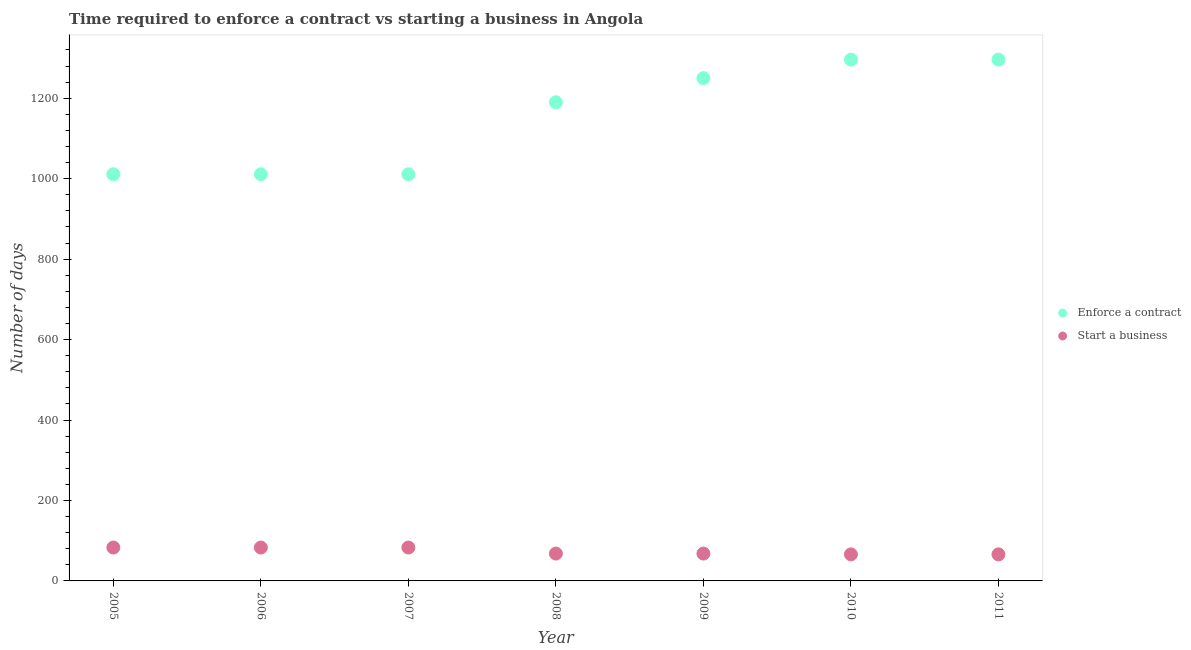What is the number of days to start a business in 2010?
Your answer should be compact. 66. Across all years, what is the maximum number of days to enforece a contract?
Make the answer very short. 1296. Across all years, what is the minimum number of days to start a business?
Offer a terse response. 66. In which year was the number of days to start a business maximum?
Provide a succinct answer. 2005. What is the total number of days to start a business in the graph?
Your response must be concise. 517. What is the difference between the number of days to start a business in 2006 and that in 2007?
Provide a succinct answer. 0. What is the difference between the number of days to enforece a contract in 2010 and the number of days to start a business in 2008?
Give a very brief answer. 1228. What is the average number of days to start a business per year?
Your response must be concise. 73.86. In the year 2010, what is the difference between the number of days to enforece a contract and number of days to start a business?
Make the answer very short. 1230. What is the ratio of the number of days to start a business in 2006 to that in 2007?
Keep it short and to the point. 1. What is the difference between the highest and the second highest number of days to enforece a contract?
Keep it short and to the point. 0. What is the difference between the highest and the lowest number of days to start a business?
Provide a short and direct response. 17. Is the sum of the number of days to enforece a contract in 2005 and 2010 greater than the maximum number of days to start a business across all years?
Keep it short and to the point. Yes. Does the number of days to enforece a contract monotonically increase over the years?
Offer a very short reply. No. Is the number of days to enforece a contract strictly greater than the number of days to start a business over the years?
Give a very brief answer. Yes. How many dotlines are there?
Provide a succinct answer. 2. Are the values on the major ticks of Y-axis written in scientific E-notation?
Your answer should be very brief. No. Does the graph contain any zero values?
Your response must be concise. No. Does the graph contain grids?
Make the answer very short. No. Where does the legend appear in the graph?
Your response must be concise. Center right. How many legend labels are there?
Keep it short and to the point. 2. How are the legend labels stacked?
Offer a terse response. Vertical. What is the title of the graph?
Your answer should be compact. Time required to enforce a contract vs starting a business in Angola. What is the label or title of the Y-axis?
Your answer should be compact. Number of days. What is the Number of days in Enforce a contract in 2005?
Your answer should be compact. 1011. What is the Number of days of Enforce a contract in 2006?
Provide a succinct answer. 1011. What is the Number of days of Start a business in 2006?
Offer a terse response. 83. What is the Number of days of Enforce a contract in 2007?
Your answer should be very brief. 1011. What is the Number of days of Start a business in 2007?
Make the answer very short. 83. What is the Number of days of Enforce a contract in 2008?
Your response must be concise. 1190. What is the Number of days in Start a business in 2008?
Your answer should be very brief. 68. What is the Number of days in Enforce a contract in 2009?
Ensure brevity in your answer.  1250. What is the Number of days in Start a business in 2009?
Keep it short and to the point. 68. What is the Number of days of Enforce a contract in 2010?
Provide a succinct answer. 1296. What is the Number of days in Enforce a contract in 2011?
Your answer should be compact. 1296. Across all years, what is the maximum Number of days in Enforce a contract?
Your response must be concise. 1296. Across all years, what is the maximum Number of days in Start a business?
Make the answer very short. 83. Across all years, what is the minimum Number of days in Enforce a contract?
Offer a very short reply. 1011. Across all years, what is the minimum Number of days of Start a business?
Provide a short and direct response. 66. What is the total Number of days in Enforce a contract in the graph?
Your answer should be very brief. 8065. What is the total Number of days in Start a business in the graph?
Provide a succinct answer. 517. What is the difference between the Number of days in Enforce a contract in 2005 and that in 2006?
Your answer should be compact. 0. What is the difference between the Number of days in Enforce a contract in 2005 and that in 2007?
Offer a terse response. 0. What is the difference between the Number of days in Enforce a contract in 2005 and that in 2008?
Provide a short and direct response. -179. What is the difference between the Number of days in Start a business in 2005 and that in 2008?
Give a very brief answer. 15. What is the difference between the Number of days of Enforce a contract in 2005 and that in 2009?
Your answer should be compact. -239. What is the difference between the Number of days in Enforce a contract in 2005 and that in 2010?
Your response must be concise. -285. What is the difference between the Number of days of Start a business in 2005 and that in 2010?
Provide a succinct answer. 17. What is the difference between the Number of days of Enforce a contract in 2005 and that in 2011?
Your response must be concise. -285. What is the difference between the Number of days in Start a business in 2006 and that in 2007?
Give a very brief answer. 0. What is the difference between the Number of days of Enforce a contract in 2006 and that in 2008?
Make the answer very short. -179. What is the difference between the Number of days in Start a business in 2006 and that in 2008?
Your answer should be compact. 15. What is the difference between the Number of days in Enforce a contract in 2006 and that in 2009?
Ensure brevity in your answer.  -239. What is the difference between the Number of days of Enforce a contract in 2006 and that in 2010?
Provide a succinct answer. -285. What is the difference between the Number of days of Enforce a contract in 2006 and that in 2011?
Keep it short and to the point. -285. What is the difference between the Number of days in Enforce a contract in 2007 and that in 2008?
Your response must be concise. -179. What is the difference between the Number of days of Start a business in 2007 and that in 2008?
Give a very brief answer. 15. What is the difference between the Number of days in Enforce a contract in 2007 and that in 2009?
Provide a succinct answer. -239. What is the difference between the Number of days of Start a business in 2007 and that in 2009?
Your answer should be compact. 15. What is the difference between the Number of days of Enforce a contract in 2007 and that in 2010?
Your answer should be compact. -285. What is the difference between the Number of days in Start a business in 2007 and that in 2010?
Provide a succinct answer. 17. What is the difference between the Number of days of Enforce a contract in 2007 and that in 2011?
Offer a terse response. -285. What is the difference between the Number of days in Start a business in 2007 and that in 2011?
Ensure brevity in your answer.  17. What is the difference between the Number of days in Enforce a contract in 2008 and that in 2009?
Provide a succinct answer. -60. What is the difference between the Number of days of Enforce a contract in 2008 and that in 2010?
Your answer should be very brief. -106. What is the difference between the Number of days in Start a business in 2008 and that in 2010?
Provide a succinct answer. 2. What is the difference between the Number of days of Enforce a contract in 2008 and that in 2011?
Offer a terse response. -106. What is the difference between the Number of days in Enforce a contract in 2009 and that in 2010?
Offer a terse response. -46. What is the difference between the Number of days of Start a business in 2009 and that in 2010?
Your answer should be compact. 2. What is the difference between the Number of days of Enforce a contract in 2009 and that in 2011?
Give a very brief answer. -46. What is the difference between the Number of days of Start a business in 2009 and that in 2011?
Give a very brief answer. 2. What is the difference between the Number of days of Enforce a contract in 2005 and the Number of days of Start a business in 2006?
Provide a short and direct response. 928. What is the difference between the Number of days in Enforce a contract in 2005 and the Number of days in Start a business in 2007?
Make the answer very short. 928. What is the difference between the Number of days in Enforce a contract in 2005 and the Number of days in Start a business in 2008?
Keep it short and to the point. 943. What is the difference between the Number of days of Enforce a contract in 2005 and the Number of days of Start a business in 2009?
Your response must be concise. 943. What is the difference between the Number of days of Enforce a contract in 2005 and the Number of days of Start a business in 2010?
Give a very brief answer. 945. What is the difference between the Number of days of Enforce a contract in 2005 and the Number of days of Start a business in 2011?
Make the answer very short. 945. What is the difference between the Number of days in Enforce a contract in 2006 and the Number of days in Start a business in 2007?
Give a very brief answer. 928. What is the difference between the Number of days of Enforce a contract in 2006 and the Number of days of Start a business in 2008?
Offer a terse response. 943. What is the difference between the Number of days of Enforce a contract in 2006 and the Number of days of Start a business in 2009?
Offer a terse response. 943. What is the difference between the Number of days in Enforce a contract in 2006 and the Number of days in Start a business in 2010?
Give a very brief answer. 945. What is the difference between the Number of days of Enforce a contract in 2006 and the Number of days of Start a business in 2011?
Keep it short and to the point. 945. What is the difference between the Number of days in Enforce a contract in 2007 and the Number of days in Start a business in 2008?
Offer a terse response. 943. What is the difference between the Number of days in Enforce a contract in 2007 and the Number of days in Start a business in 2009?
Make the answer very short. 943. What is the difference between the Number of days in Enforce a contract in 2007 and the Number of days in Start a business in 2010?
Your answer should be compact. 945. What is the difference between the Number of days in Enforce a contract in 2007 and the Number of days in Start a business in 2011?
Make the answer very short. 945. What is the difference between the Number of days of Enforce a contract in 2008 and the Number of days of Start a business in 2009?
Make the answer very short. 1122. What is the difference between the Number of days of Enforce a contract in 2008 and the Number of days of Start a business in 2010?
Provide a short and direct response. 1124. What is the difference between the Number of days of Enforce a contract in 2008 and the Number of days of Start a business in 2011?
Offer a terse response. 1124. What is the difference between the Number of days in Enforce a contract in 2009 and the Number of days in Start a business in 2010?
Offer a terse response. 1184. What is the difference between the Number of days of Enforce a contract in 2009 and the Number of days of Start a business in 2011?
Offer a terse response. 1184. What is the difference between the Number of days of Enforce a contract in 2010 and the Number of days of Start a business in 2011?
Provide a succinct answer. 1230. What is the average Number of days in Enforce a contract per year?
Your response must be concise. 1152.14. What is the average Number of days of Start a business per year?
Provide a short and direct response. 73.86. In the year 2005, what is the difference between the Number of days in Enforce a contract and Number of days in Start a business?
Provide a succinct answer. 928. In the year 2006, what is the difference between the Number of days of Enforce a contract and Number of days of Start a business?
Provide a succinct answer. 928. In the year 2007, what is the difference between the Number of days in Enforce a contract and Number of days in Start a business?
Give a very brief answer. 928. In the year 2008, what is the difference between the Number of days in Enforce a contract and Number of days in Start a business?
Your answer should be very brief. 1122. In the year 2009, what is the difference between the Number of days of Enforce a contract and Number of days of Start a business?
Offer a terse response. 1182. In the year 2010, what is the difference between the Number of days of Enforce a contract and Number of days of Start a business?
Your answer should be very brief. 1230. In the year 2011, what is the difference between the Number of days in Enforce a contract and Number of days in Start a business?
Offer a very short reply. 1230. What is the ratio of the Number of days of Enforce a contract in 2005 to that in 2006?
Provide a short and direct response. 1. What is the ratio of the Number of days in Start a business in 2005 to that in 2006?
Offer a very short reply. 1. What is the ratio of the Number of days in Enforce a contract in 2005 to that in 2008?
Offer a terse response. 0.85. What is the ratio of the Number of days in Start a business in 2005 to that in 2008?
Give a very brief answer. 1.22. What is the ratio of the Number of days in Enforce a contract in 2005 to that in 2009?
Provide a succinct answer. 0.81. What is the ratio of the Number of days in Start a business in 2005 to that in 2009?
Keep it short and to the point. 1.22. What is the ratio of the Number of days in Enforce a contract in 2005 to that in 2010?
Make the answer very short. 0.78. What is the ratio of the Number of days of Start a business in 2005 to that in 2010?
Offer a very short reply. 1.26. What is the ratio of the Number of days in Enforce a contract in 2005 to that in 2011?
Your answer should be very brief. 0.78. What is the ratio of the Number of days of Start a business in 2005 to that in 2011?
Provide a short and direct response. 1.26. What is the ratio of the Number of days in Start a business in 2006 to that in 2007?
Your answer should be very brief. 1. What is the ratio of the Number of days of Enforce a contract in 2006 to that in 2008?
Ensure brevity in your answer.  0.85. What is the ratio of the Number of days in Start a business in 2006 to that in 2008?
Keep it short and to the point. 1.22. What is the ratio of the Number of days in Enforce a contract in 2006 to that in 2009?
Offer a very short reply. 0.81. What is the ratio of the Number of days in Start a business in 2006 to that in 2009?
Give a very brief answer. 1.22. What is the ratio of the Number of days of Enforce a contract in 2006 to that in 2010?
Offer a terse response. 0.78. What is the ratio of the Number of days in Start a business in 2006 to that in 2010?
Make the answer very short. 1.26. What is the ratio of the Number of days of Enforce a contract in 2006 to that in 2011?
Give a very brief answer. 0.78. What is the ratio of the Number of days of Start a business in 2006 to that in 2011?
Keep it short and to the point. 1.26. What is the ratio of the Number of days of Enforce a contract in 2007 to that in 2008?
Provide a succinct answer. 0.85. What is the ratio of the Number of days in Start a business in 2007 to that in 2008?
Give a very brief answer. 1.22. What is the ratio of the Number of days in Enforce a contract in 2007 to that in 2009?
Keep it short and to the point. 0.81. What is the ratio of the Number of days of Start a business in 2007 to that in 2009?
Provide a succinct answer. 1.22. What is the ratio of the Number of days in Enforce a contract in 2007 to that in 2010?
Offer a terse response. 0.78. What is the ratio of the Number of days in Start a business in 2007 to that in 2010?
Offer a very short reply. 1.26. What is the ratio of the Number of days of Enforce a contract in 2007 to that in 2011?
Ensure brevity in your answer.  0.78. What is the ratio of the Number of days of Start a business in 2007 to that in 2011?
Provide a short and direct response. 1.26. What is the ratio of the Number of days of Enforce a contract in 2008 to that in 2010?
Your answer should be very brief. 0.92. What is the ratio of the Number of days of Start a business in 2008 to that in 2010?
Provide a short and direct response. 1.03. What is the ratio of the Number of days in Enforce a contract in 2008 to that in 2011?
Your answer should be compact. 0.92. What is the ratio of the Number of days in Start a business in 2008 to that in 2011?
Offer a terse response. 1.03. What is the ratio of the Number of days in Enforce a contract in 2009 to that in 2010?
Your answer should be compact. 0.96. What is the ratio of the Number of days in Start a business in 2009 to that in 2010?
Your answer should be very brief. 1.03. What is the ratio of the Number of days in Enforce a contract in 2009 to that in 2011?
Your response must be concise. 0.96. What is the ratio of the Number of days in Start a business in 2009 to that in 2011?
Make the answer very short. 1.03. What is the difference between the highest and the second highest Number of days in Enforce a contract?
Make the answer very short. 0. What is the difference between the highest and the second highest Number of days in Start a business?
Provide a succinct answer. 0. What is the difference between the highest and the lowest Number of days in Enforce a contract?
Offer a very short reply. 285. What is the difference between the highest and the lowest Number of days of Start a business?
Ensure brevity in your answer.  17. 